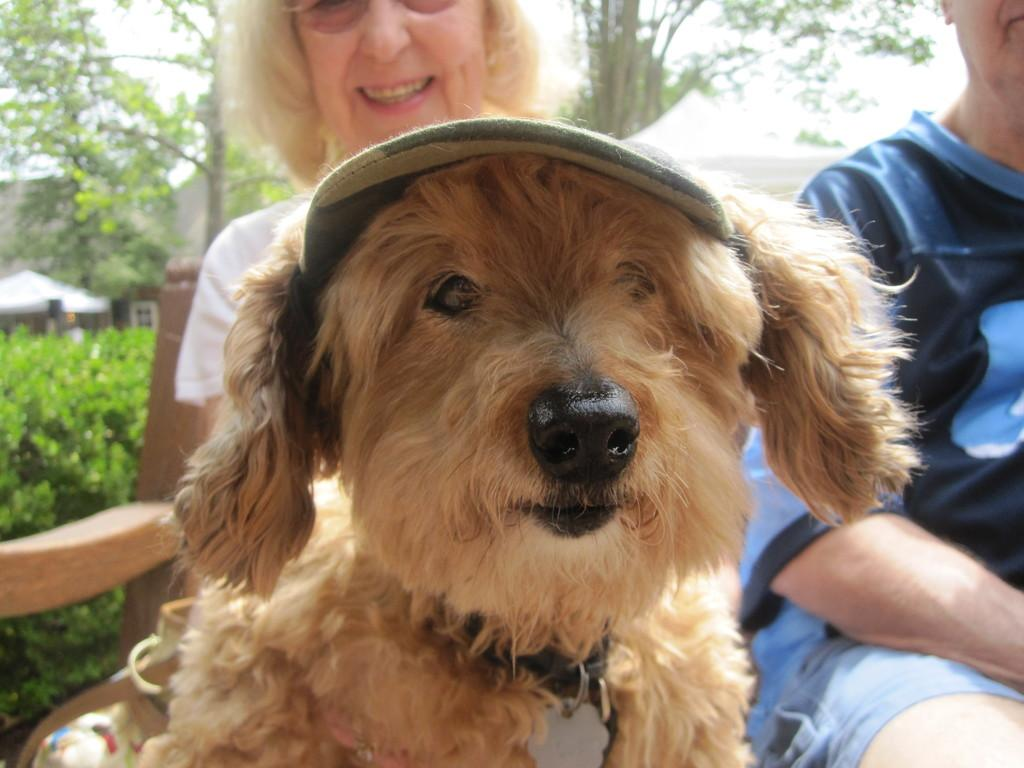What type of animal is in the image? There is a dog in the image. What can be seen in the background of the image? There are people and trees in the background of the image. What type of cracker is the dog holding in the image? There is no cracker present in the image; it only features a dog and people in the background. 